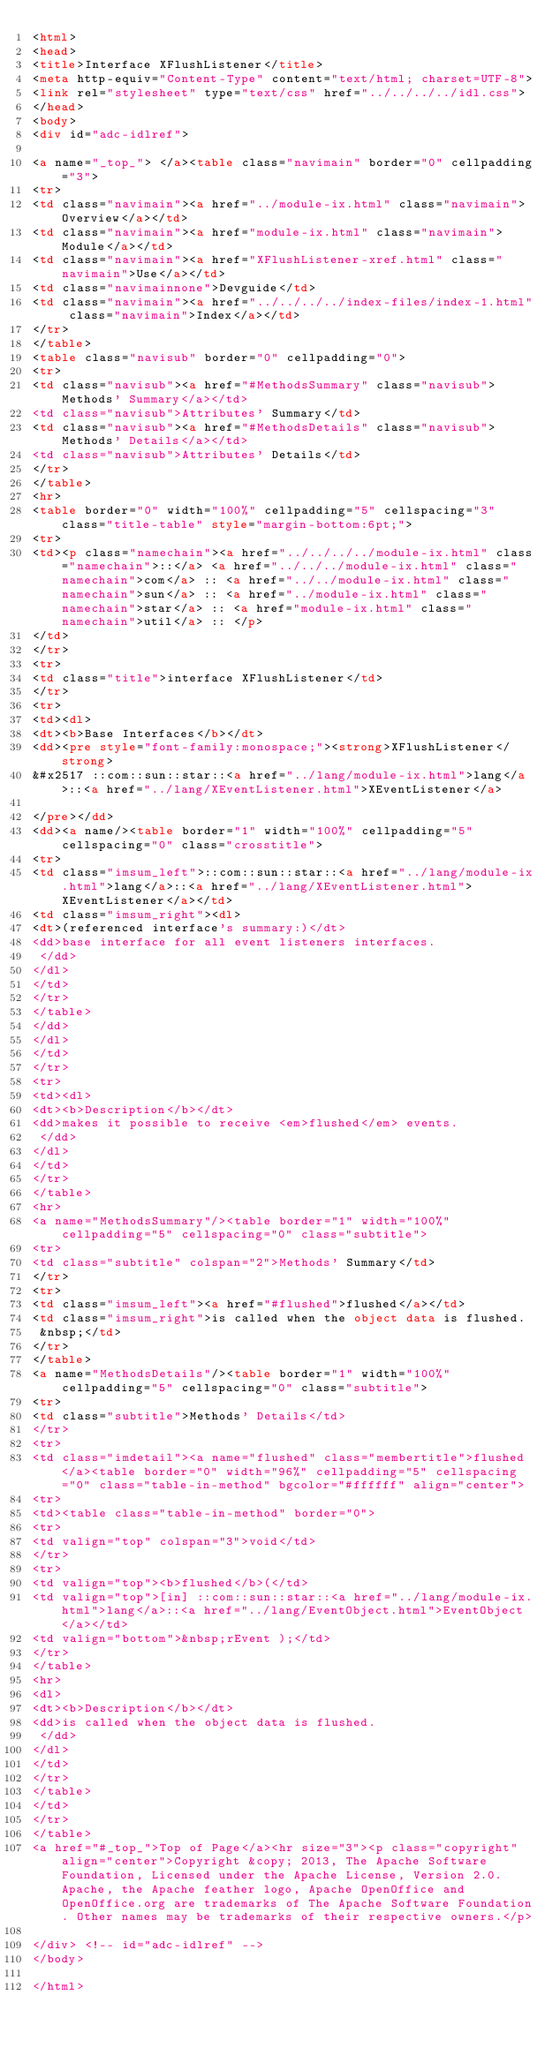<code> <loc_0><loc_0><loc_500><loc_500><_HTML_><html>
<head>
<title>Interface XFlushListener</title>
<meta http-equiv="Content-Type" content="text/html; charset=UTF-8">
<link rel="stylesheet" type="text/css" href="../../../../idl.css">
</head>
<body>
<div id="adc-idlref">

<a name="_top_"> </a><table class="navimain" border="0" cellpadding="3">
<tr>
<td class="navimain"><a href="../module-ix.html" class="navimain">Overview</a></td>
<td class="navimain"><a href="module-ix.html" class="navimain">Module</a></td>
<td class="navimain"><a href="XFlushListener-xref.html" class="navimain">Use</a></td>
<td class="navimainnone">Devguide</td>
<td class="navimain"><a href="../../../../index-files/index-1.html" class="navimain">Index</a></td>
</tr>
</table>
<table class="navisub" border="0" cellpadding="0">
<tr>
<td class="navisub"><a href="#MethodsSummary" class="navisub">Methods' Summary</a></td>
<td class="navisub">Attributes' Summary</td>
<td class="navisub"><a href="#MethodsDetails" class="navisub">Methods' Details</a></td>
<td class="navisub">Attributes' Details</td>
</tr>
</table>
<hr>
<table border="0" width="100%" cellpadding="5" cellspacing="3" class="title-table" style="margin-bottom:6pt;">
<tr>
<td><p class="namechain"><a href="../../../../module-ix.html" class="namechain">::</a> <a href="../../../module-ix.html" class="namechain">com</a> :: <a href="../../module-ix.html" class="namechain">sun</a> :: <a href="../module-ix.html" class="namechain">star</a> :: <a href="module-ix.html" class="namechain">util</a> :: </p>
</td>
</tr>
<tr>
<td class="title">interface XFlushListener</td>
</tr>
<tr>
<td><dl>
<dt><b>Base Interfaces</b></dt>
<dd><pre style="font-family:monospace;"><strong>XFlushListener</strong>
&#x2517 ::com::sun::star::<a href="../lang/module-ix.html">lang</a>::<a href="../lang/XEventListener.html">XEventListener</a>

</pre></dd>
<dd><a name/><table border="1" width="100%" cellpadding="5" cellspacing="0" class="crosstitle">
<tr>
<td class="imsum_left">::com::sun::star::<a href="../lang/module-ix.html">lang</a>::<a href="../lang/XEventListener.html">XEventListener</a></td>
<td class="imsum_right"><dl>
<dt>(referenced interface's summary:)</dt>
<dd>base interface for all event listeners interfaces.
 </dd>
</dl>
</td>
</tr>
</table>
</dd>
</dl>
</td>
</tr>
<tr>
<td><dl>
<dt><b>Description</b></dt>
<dd>makes it possible to receive <em>flushed</em> events.
 </dd>
</dl>
</td>
</tr>
</table>
<hr>
<a name="MethodsSummary"/><table border="1" width="100%" cellpadding="5" cellspacing="0" class="subtitle">
<tr>
<td class="subtitle" colspan="2">Methods' Summary</td>
</tr>
<tr>
<td class="imsum_left"><a href="#flushed">flushed</a></td>
<td class="imsum_right">is called when the object data is flushed.
 &nbsp;</td>
</tr>
</table>
<a name="MethodsDetails"/><table border="1" width="100%" cellpadding="5" cellspacing="0" class="subtitle">
<tr>
<td class="subtitle">Methods' Details</td>
</tr>
<tr>
<td class="imdetail"><a name="flushed" class="membertitle">flushed</a><table border="0" width="96%" cellpadding="5" cellspacing="0" class="table-in-method" bgcolor="#ffffff" align="center">
<tr>
<td><table class="table-in-method" border="0">
<tr>
<td valign="top" colspan="3">void</td>
</tr>
<tr>
<td valign="top"><b>flushed</b>(</td>
<td valign="top">[in] ::com::sun::star::<a href="../lang/module-ix.html">lang</a>::<a href="../lang/EventObject.html">EventObject</a></td>
<td valign="bottom">&nbsp;rEvent );</td>
</tr>
</table>
<hr>
<dl>
<dt><b>Description</b></dt>
<dd>is called when the object data is flushed.
 </dd>
</dl>
</td>
</tr>
</table>
</td>
</tr>
</table>
<a href="#_top_">Top of Page</a><hr size="3"><p class="copyright" align="center">Copyright &copy; 2013, The Apache Software Foundation, Licensed under the Apache License, Version 2.0. Apache, the Apache feather logo, Apache OpenOffice and OpenOffice.org are trademarks of The Apache Software Foundation. Other names may be trademarks of their respective owners.</p>

</div> <!-- id="adc-idlref" -->
</body>

</html>
</code> 